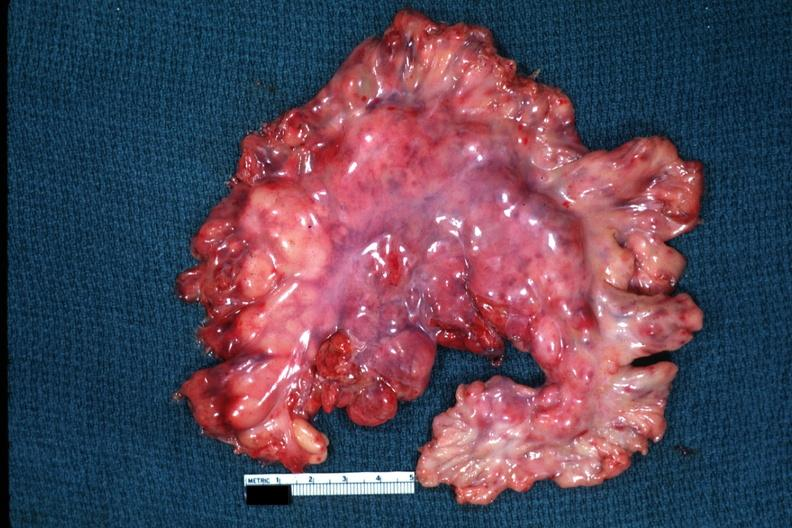does abdomen show massive node enlargement like a lymphoma?
Answer the question using a single word or phrase. No 